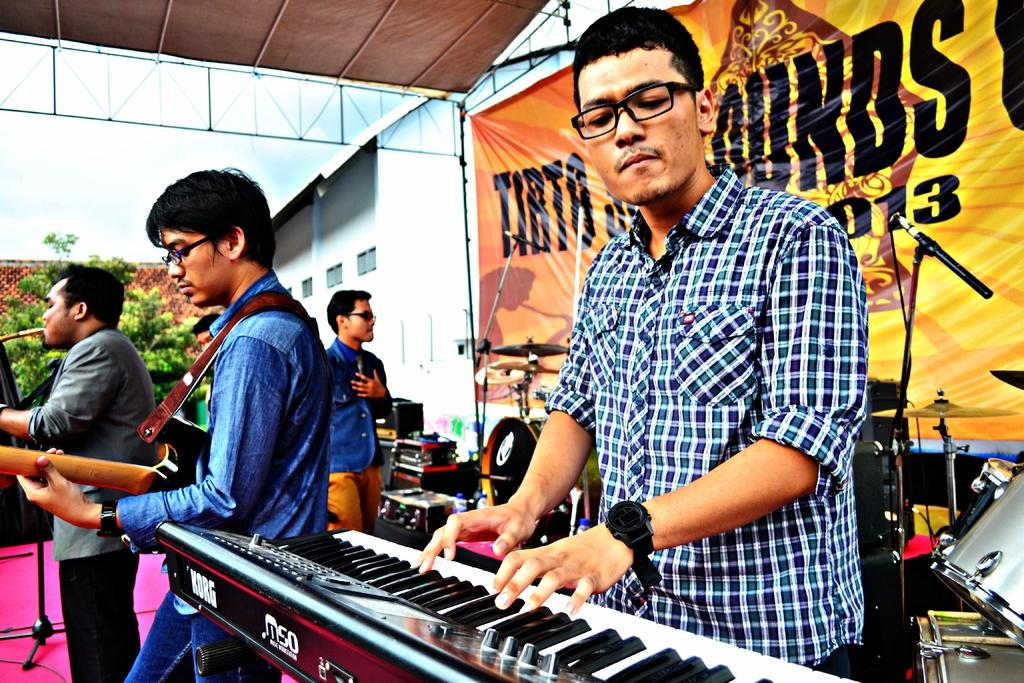What are the people in the image doing? The people in the image are holding musical instruments. What can be seen in the background of the image? There is a plant, a building, the sky, and a banner in the background of the image. How many pears are on the wing of the building in the image? There are no pears or wings present on the building in the image. 